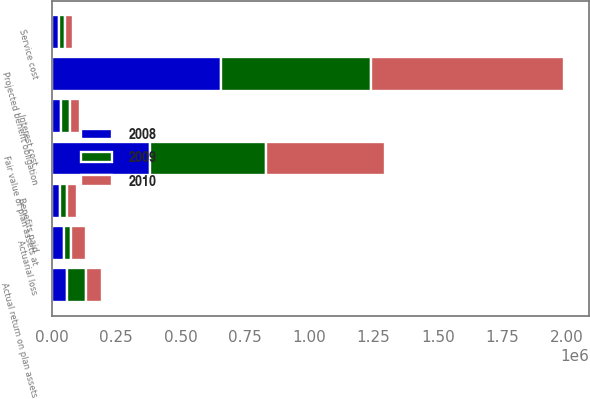Convert chart. <chart><loc_0><loc_0><loc_500><loc_500><stacked_bar_chart><ecel><fcel>Projected benefit obligation<fcel>Service cost<fcel>Interest cost<fcel>Actuarial loss<fcel>Benefits paid<fcel>Fair value of plan assets at<fcel>Actual return on plan assets<nl><fcel>2010<fcel>749284<fcel>30945<fcel>38772<fcel>56952<fcel>35549<fcel>460961<fcel>63877<nl><fcel>2008<fcel>658164<fcel>26153<fcel>36127<fcel>45515<fcel>31437<fcel>380577<fcel>59956<nl><fcel>2009<fcel>581432<fcel>22904<fcel>33440<fcel>29981<fcel>28927<fcel>452723<fcel>71459<nl></chart> 